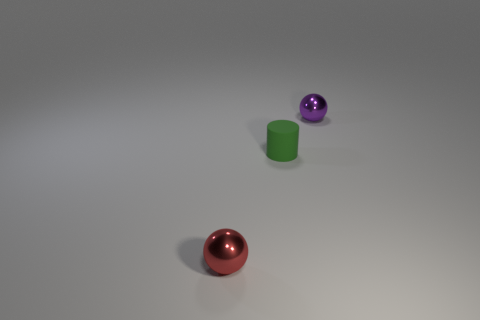How many shiny things are green cylinders or gray cylinders?
Keep it short and to the point. 0. There is a tiny metal thing left of the tiny sphere that is on the right side of the small metal object that is to the left of the tiny rubber cylinder; what is its color?
Your answer should be compact. Red. What is the color of the other small object that is the same shape as the red thing?
Your response must be concise. Purple. Is there anything else of the same color as the cylinder?
Offer a very short reply. No. What number of other objects are the same material as the tiny red object?
Give a very brief answer. 1. How big is the purple thing?
Make the answer very short. Small. Is there a large gray thing of the same shape as the small red shiny object?
Offer a terse response. No. What number of things are small red things or small objects that are in front of the tiny purple thing?
Your response must be concise. 2. What color is the metal object on the right side of the tiny red metal thing?
Offer a very short reply. Purple. Is there a object of the same size as the red metallic ball?
Offer a very short reply. Yes. 